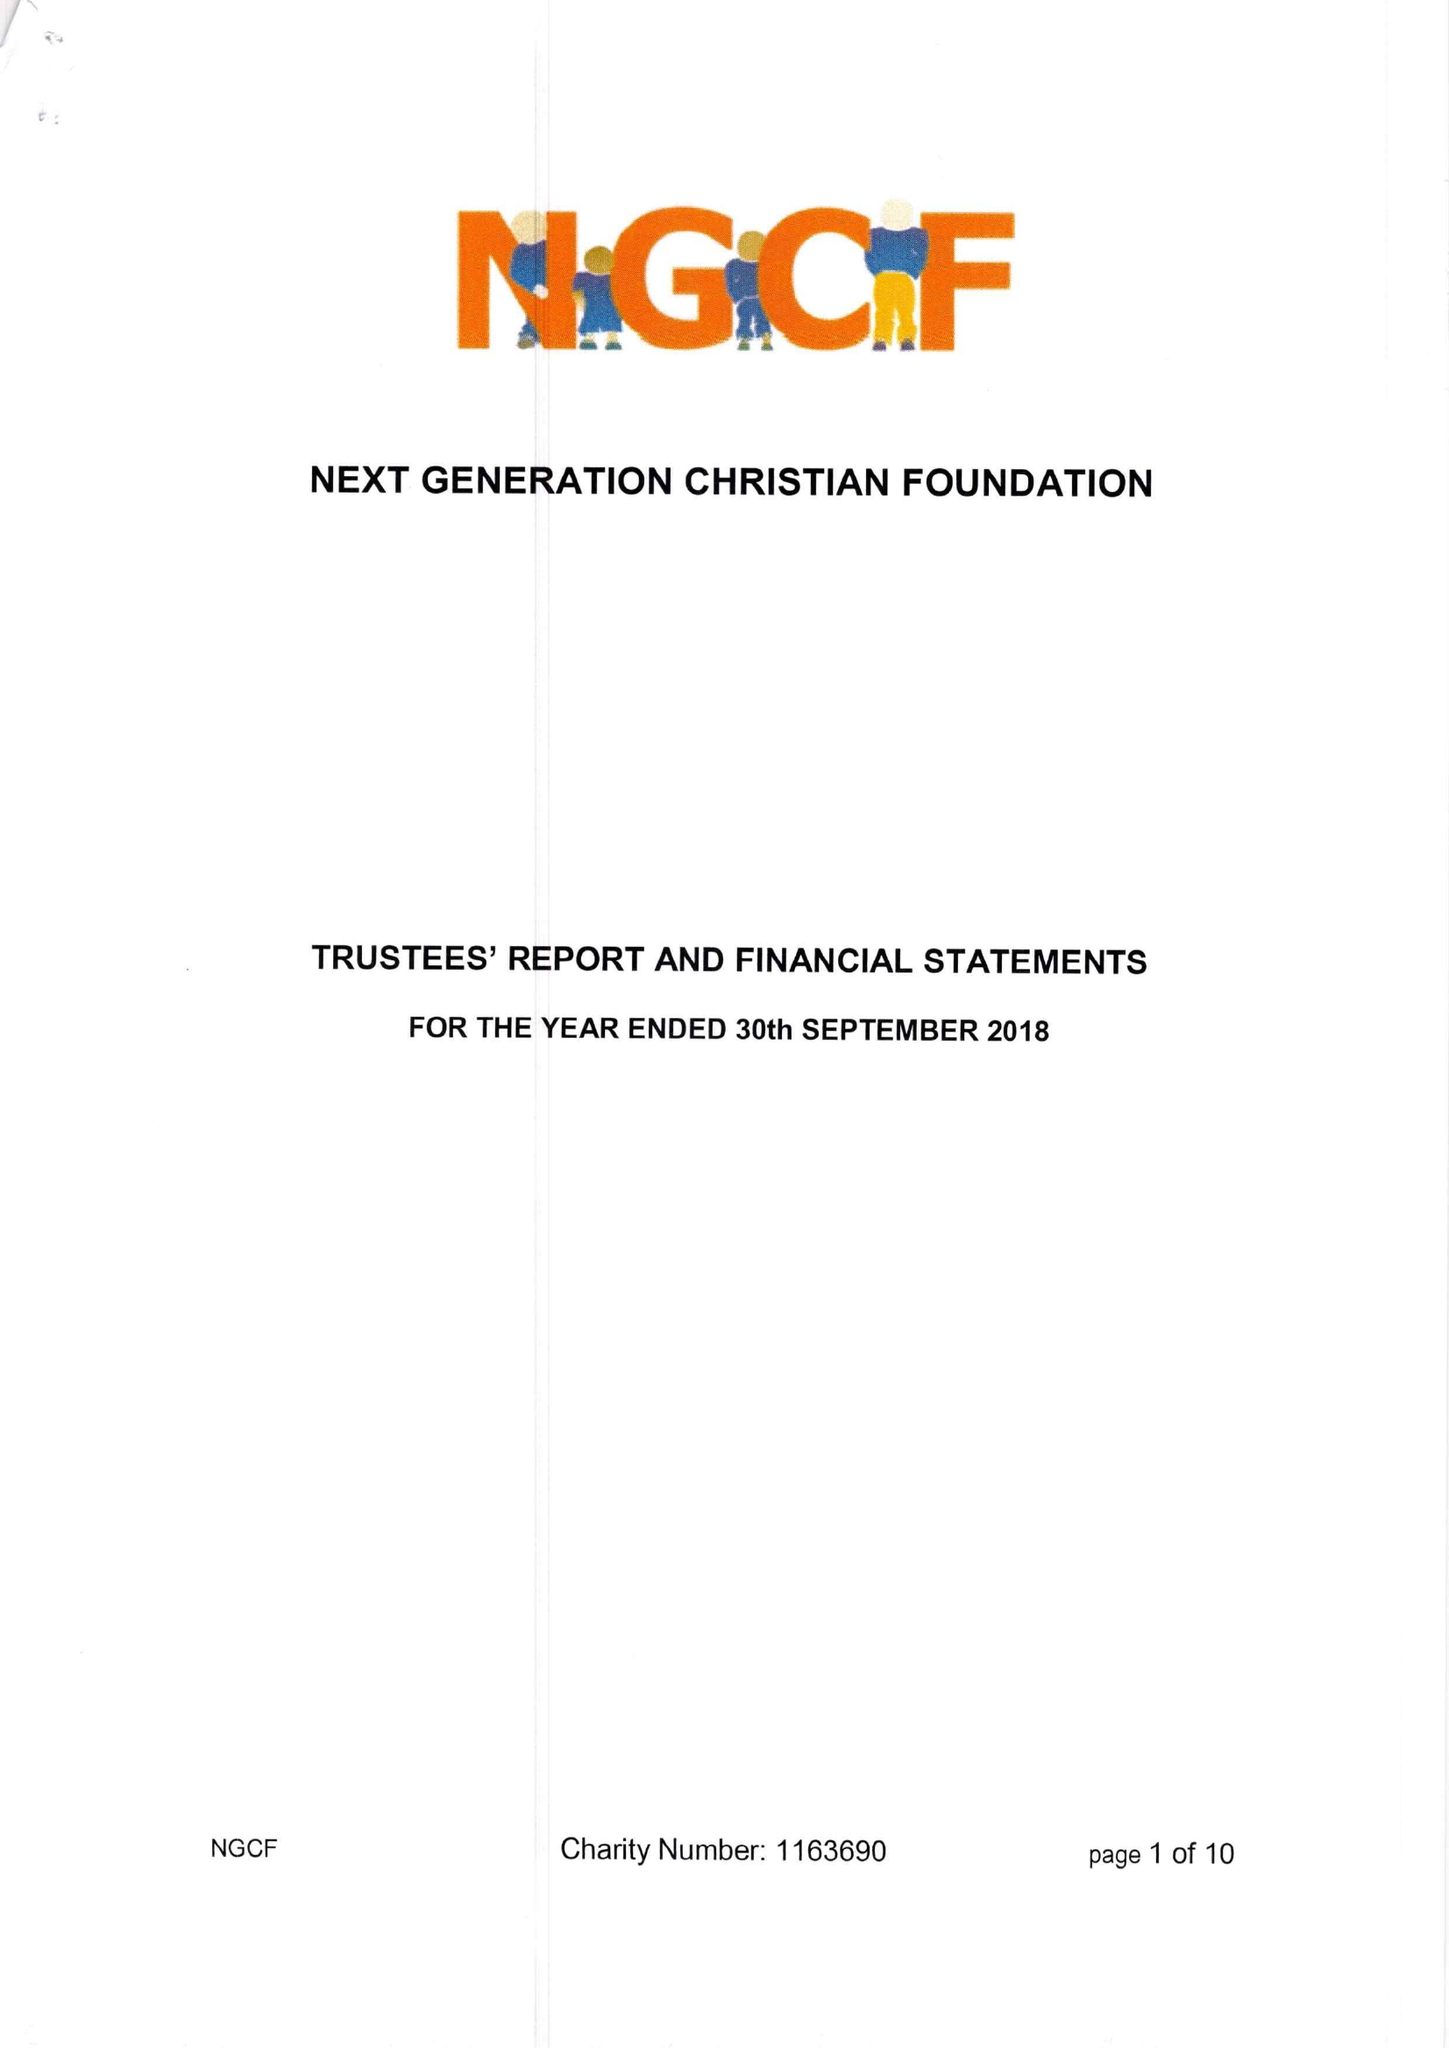What is the value for the address__post_town?
Answer the question using a single word or phrase. READING 